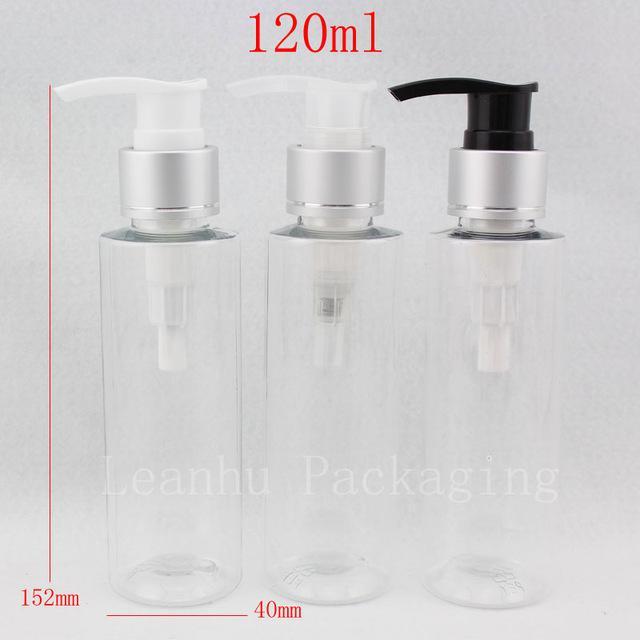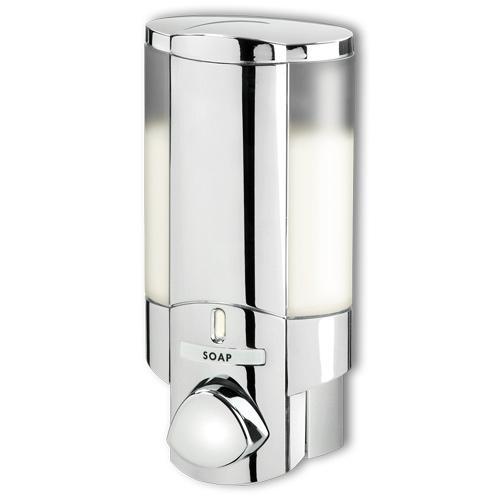The first image is the image on the left, the second image is the image on the right. For the images displayed, is the sentence "There are at least six dispensers." factually correct? Answer yes or no. No. 